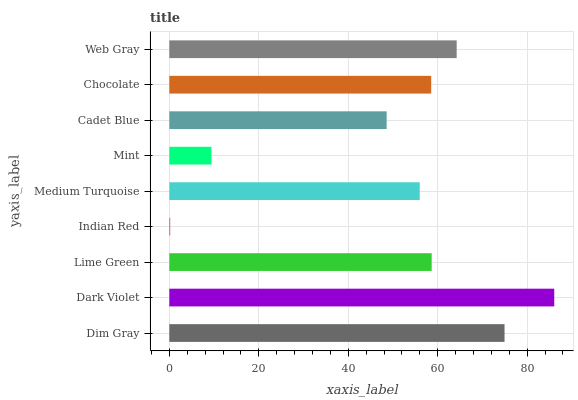Is Indian Red the minimum?
Answer yes or no. Yes. Is Dark Violet the maximum?
Answer yes or no. Yes. Is Lime Green the minimum?
Answer yes or no. No. Is Lime Green the maximum?
Answer yes or no. No. Is Dark Violet greater than Lime Green?
Answer yes or no. Yes. Is Lime Green less than Dark Violet?
Answer yes or no. Yes. Is Lime Green greater than Dark Violet?
Answer yes or no. No. Is Dark Violet less than Lime Green?
Answer yes or no. No. Is Chocolate the high median?
Answer yes or no. Yes. Is Chocolate the low median?
Answer yes or no. Yes. Is Lime Green the high median?
Answer yes or no. No. Is Cadet Blue the low median?
Answer yes or no. No. 